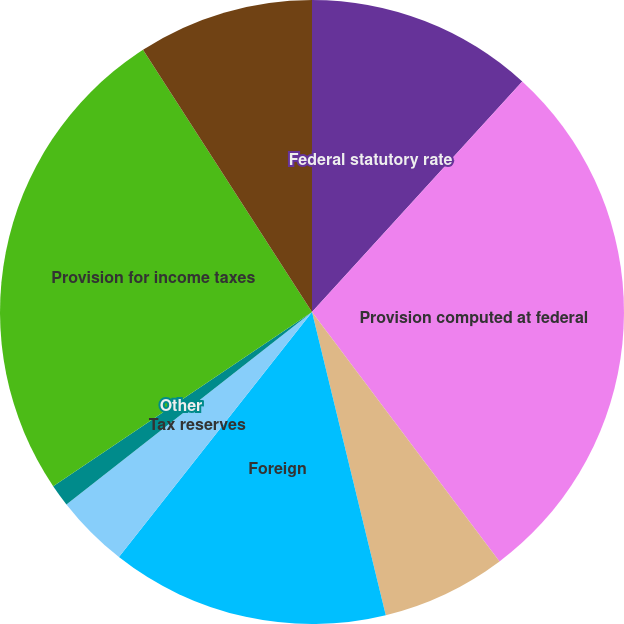Convert chart to OTSL. <chart><loc_0><loc_0><loc_500><loc_500><pie_chart><fcel>Federal statutory rate<fcel>Provision computed at federal<fcel>State and local taxes net of<fcel>Foreign<fcel>Tax reserves<fcel>Other<fcel>Provision for income taxes<fcel>Effective income tax rate<nl><fcel>11.77%<fcel>27.97%<fcel>6.46%<fcel>14.42%<fcel>3.8%<fcel>1.15%<fcel>25.32%<fcel>9.11%<nl></chart> 